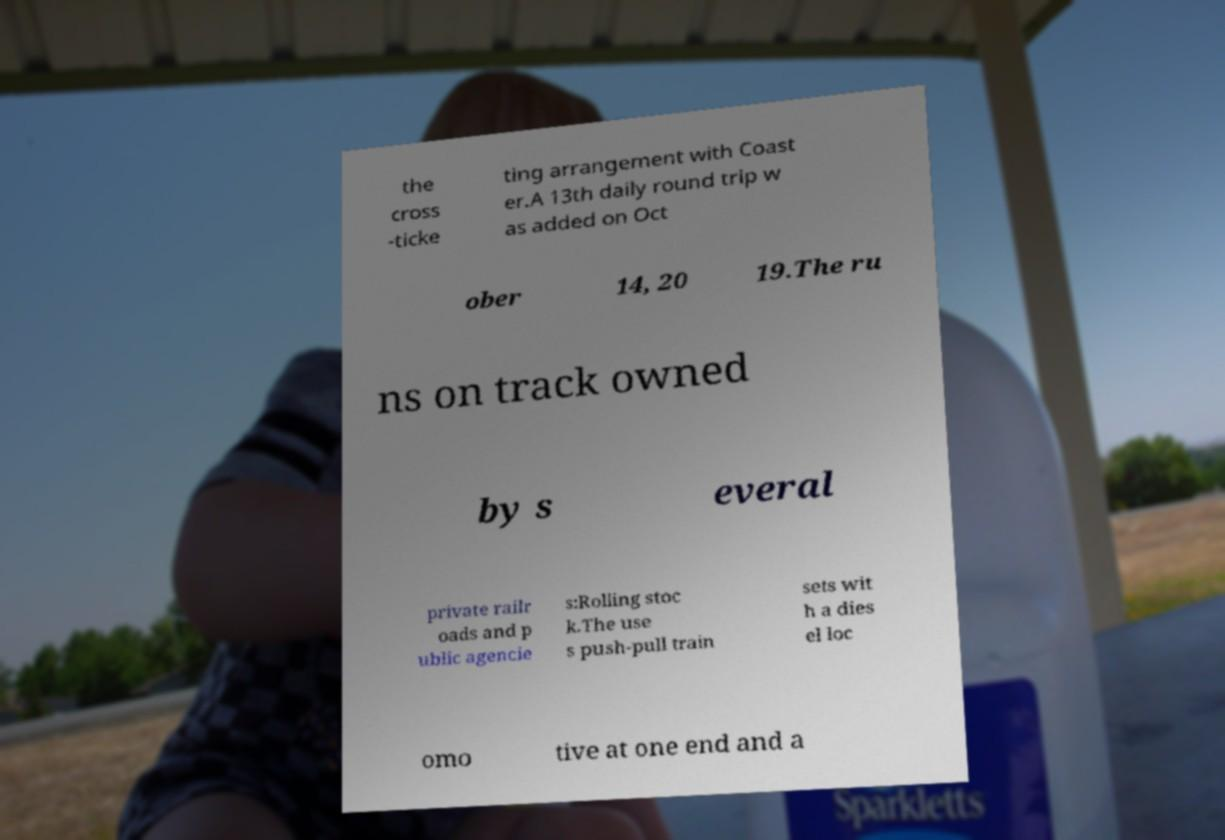There's text embedded in this image that I need extracted. Can you transcribe it verbatim? the cross -ticke ting arrangement with Coast er.A 13th daily round trip w as added on Oct ober 14, 20 19.The ru ns on track owned by s everal private railr oads and p ublic agencie s:Rolling stoc k.The use s push-pull train sets wit h a dies el loc omo tive at one end and a 